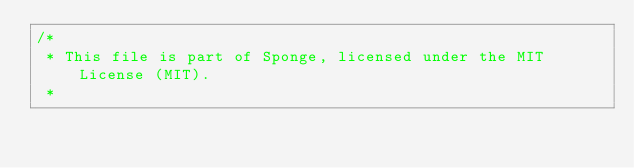Convert code to text. <code><loc_0><loc_0><loc_500><loc_500><_Java_>/*
 * This file is part of Sponge, licensed under the MIT License (MIT).
 *</code> 